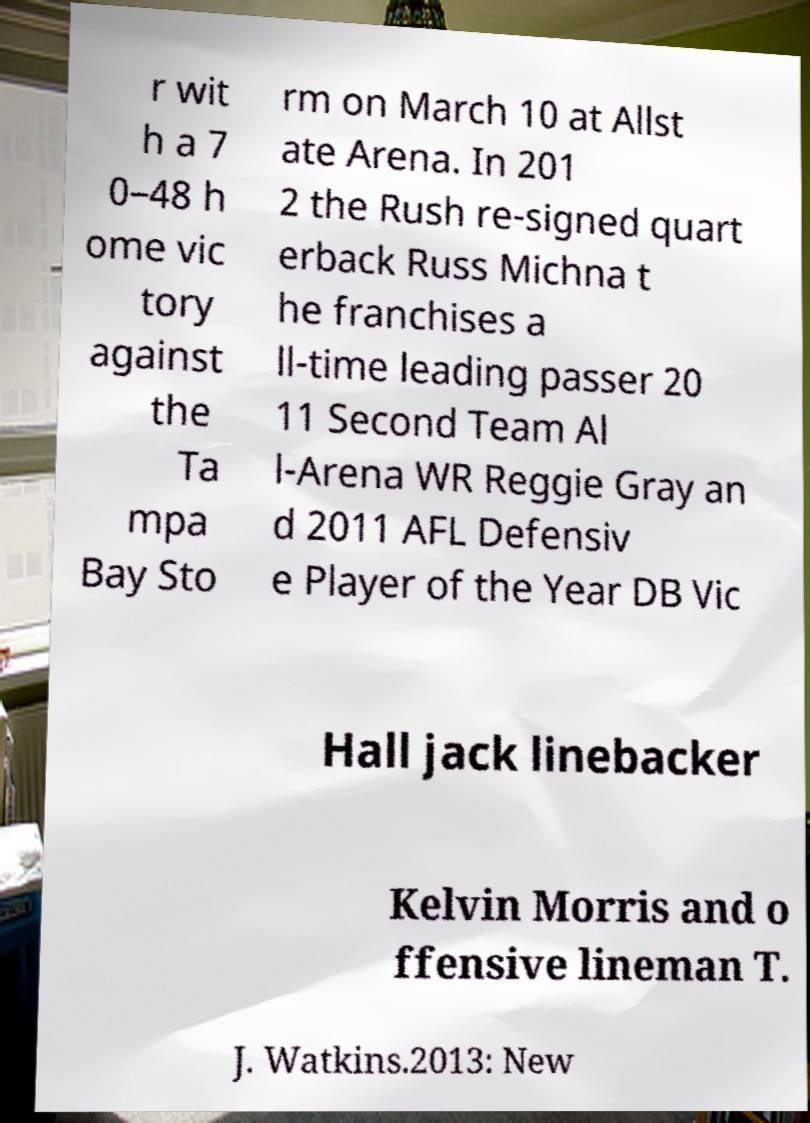There's text embedded in this image that I need extracted. Can you transcribe it verbatim? r wit h a 7 0–48 h ome vic tory against the Ta mpa Bay Sto rm on March 10 at Allst ate Arena. In 201 2 the Rush re-signed quart erback Russ Michna t he franchises a ll-time leading passer 20 11 Second Team Al l-Arena WR Reggie Gray an d 2011 AFL Defensiv e Player of the Year DB Vic Hall jack linebacker Kelvin Morris and o ffensive lineman T. J. Watkins.2013: New 